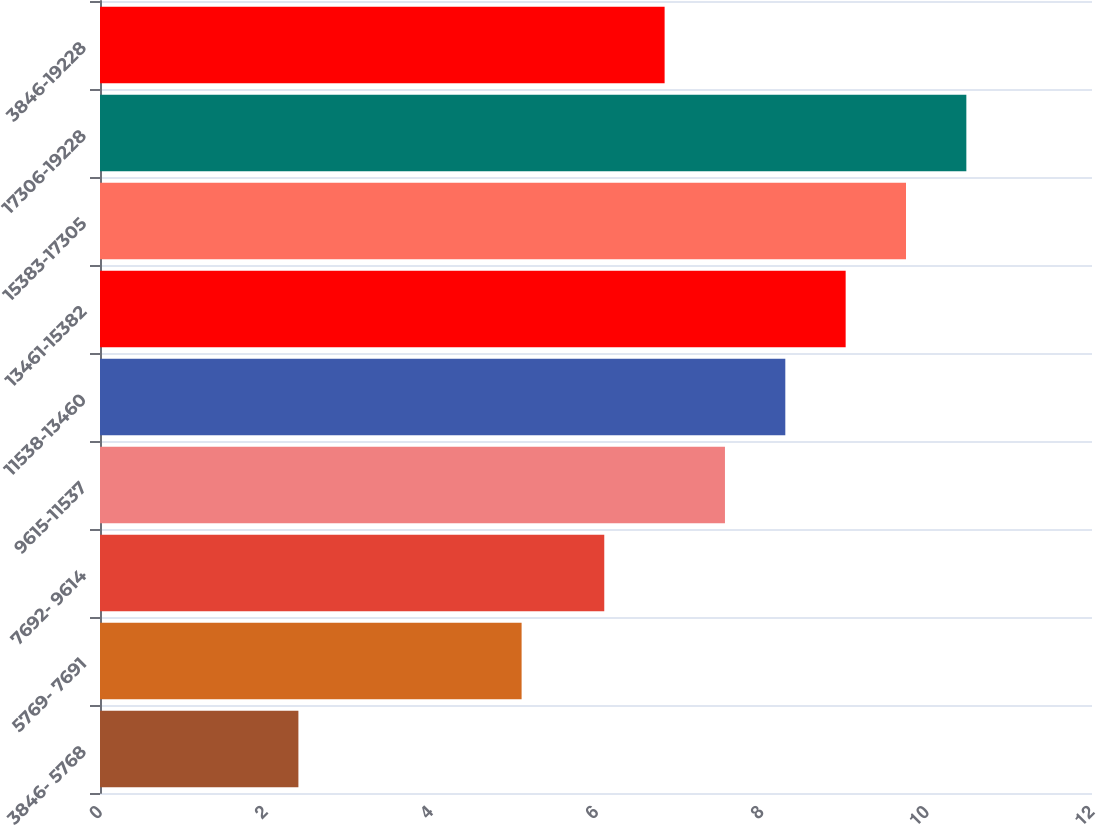Convert chart. <chart><loc_0><loc_0><loc_500><loc_500><bar_chart><fcel>3846- 5768<fcel>5769- 7691<fcel>7692- 9614<fcel>9615-11537<fcel>11538-13460<fcel>13461-15382<fcel>15383-17305<fcel>17306-19228<fcel>3846-19228<nl><fcel>2.4<fcel>5.1<fcel>6.1<fcel>7.56<fcel>8.29<fcel>9.02<fcel>9.75<fcel>10.48<fcel>6.83<nl></chart> 